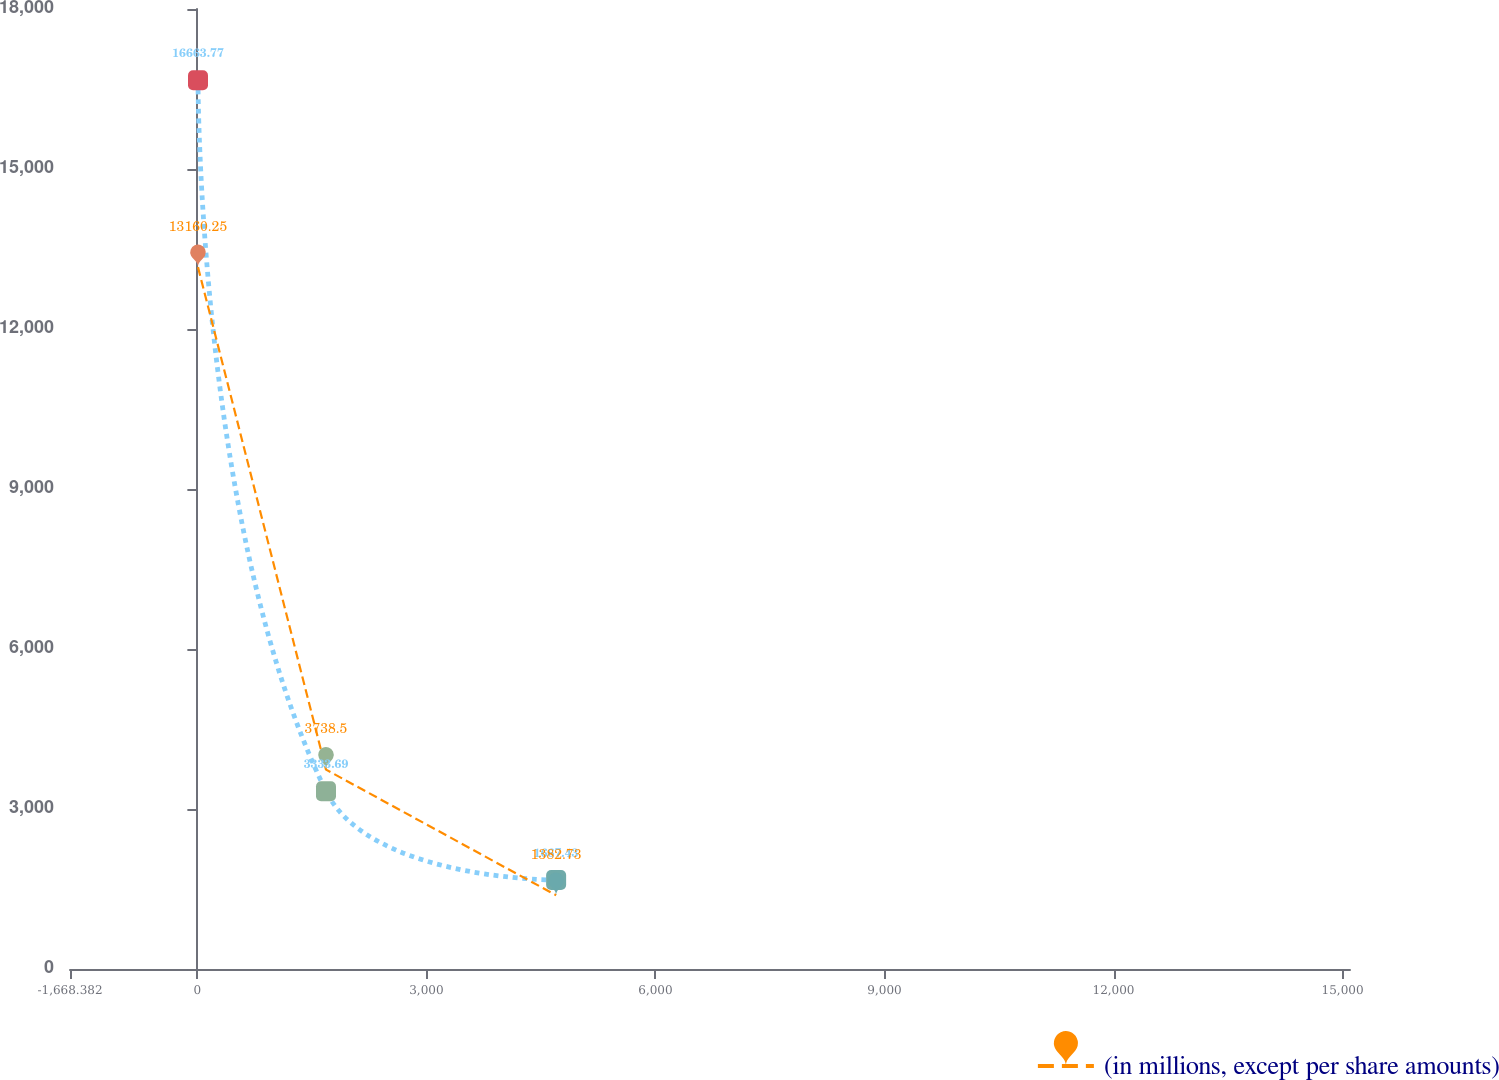<chart> <loc_0><loc_0><loc_500><loc_500><line_chart><ecel><fcel>Unnamed: 1<fcel>(in millions, except per share amounts)<nl><fcel>8.22<fcel>16663.8<fcel>13160.2<nl><fcel>1684.82<fcel>3333.69<fcel>3738.5<nl><fcel>4699.15<fcel>1667.43<fcel>1382.73<nl><fcel>16774.2<fcel>1.17<fcel>1.23<nl></chart> 